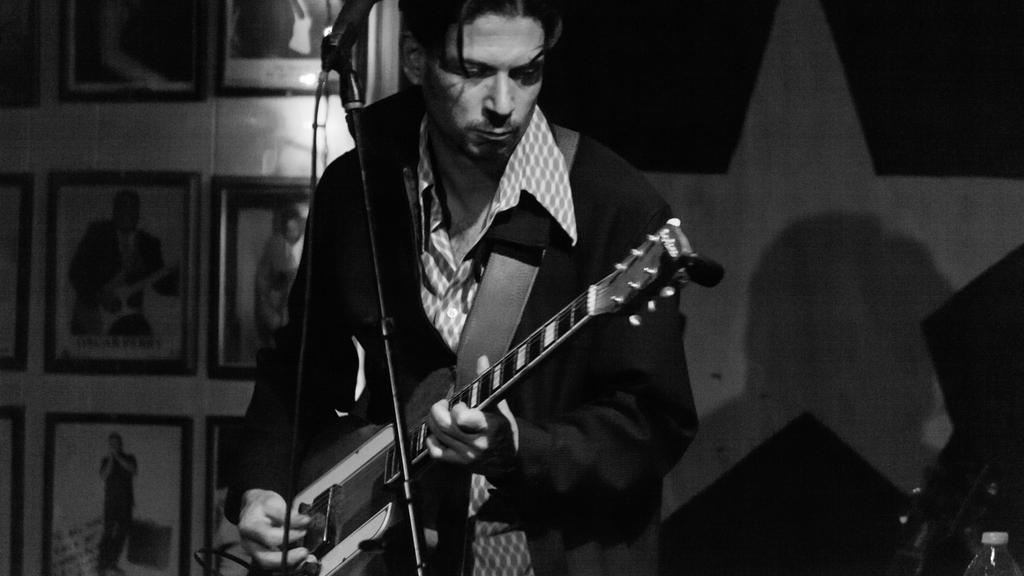What is the person in the image doing? The person is playing a guitar. What can be seen behind the person? There are photo frames at the back of the person. What objects are in the front of the person? There is a bottle and a microphone in the front of the person. How many books are on the table next to the person? There is no table or books mentioned in the provided facts, so we cannot determine the number of books in the image. 